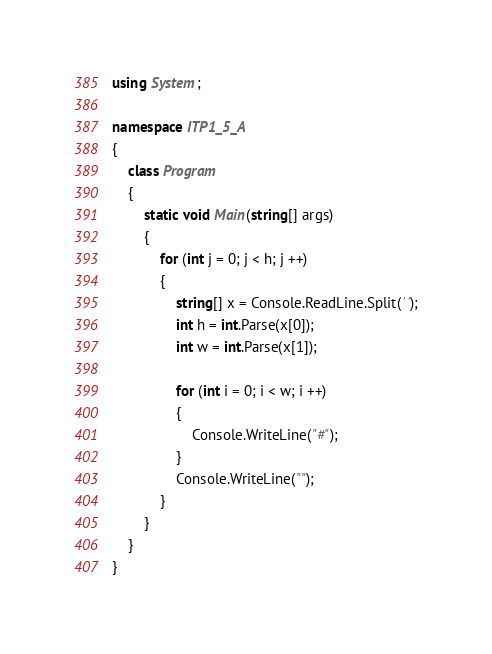Convert code to text. <code><loc_0><loc_0><loc_500><loc_500><_C#_>using System;

namespace ITP1_5_A
{
    class Program
    {
        static void Main(string[] args)
        {
            for (int j = 0; j < h; j ++)
            {
                string[] x = Console.ReadLine.Split(' ');
                int h = int.Parse(x[0]);
                int w = int.Parse(x[1]);
                
                for (int i = 0; i < w; i ++)
                {
                    Console.WriteLine("#");
                }
                Console.WriteLine("");
            }
        }
    }
}
</code> 